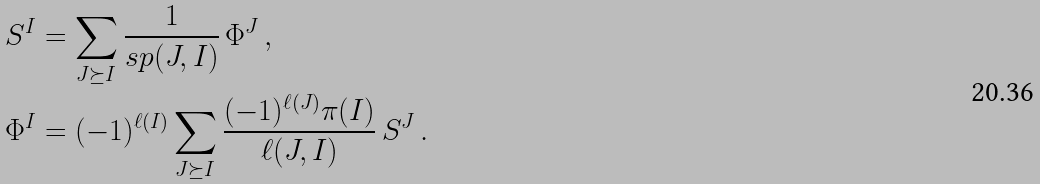<formula> <loc_0><loc_0><loc_500><loc_500>S ^ { I } & = \sum _ { J \succeq I } \frac { 1 } { s p ( J , I ) } \, \Phi ^ { J } \, , \\ \Phi ^ { I } & = ( - 1 ) ^ { \ell ( I ) } \sum _ { J \succeq I } \frac { ( - 1 ) ^ { \ell ( J ) } \pi ( I ) } { \ell ( J , I ) } \, S ^ { J } \, .</formula> 